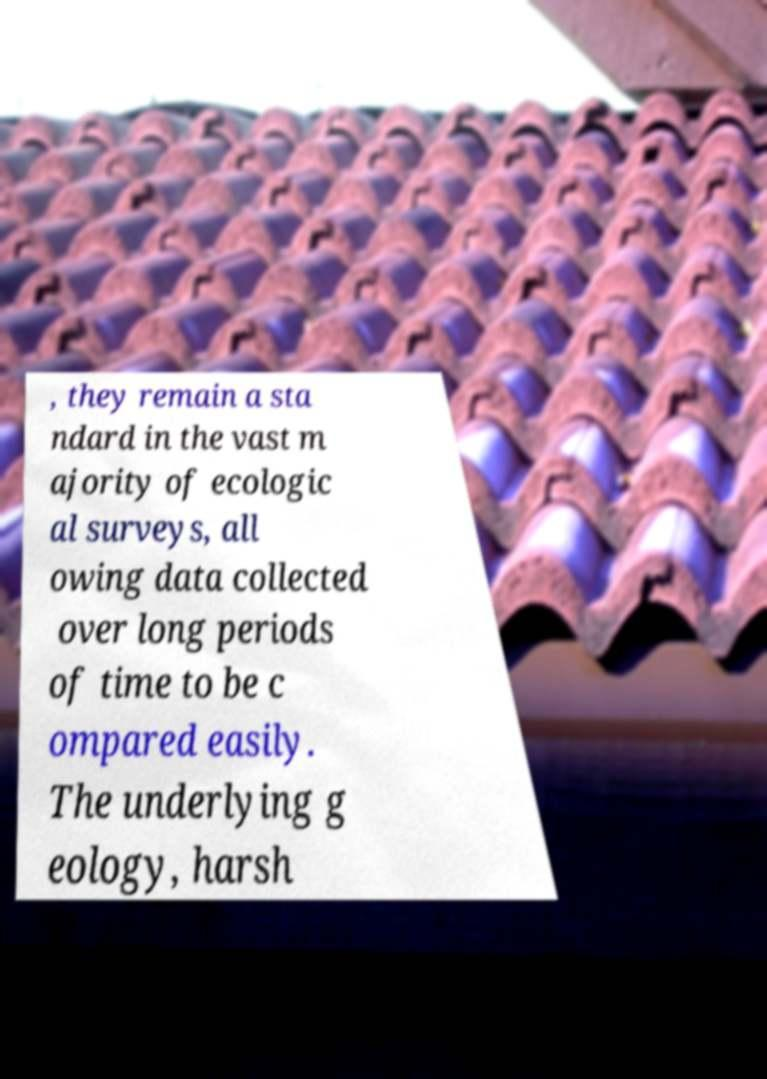Could you extract and type out the text from this image? , they remain a sta ndard in the vast m ajority of ecologic al surveys, all owing data collected over long periods of time to be c ompared easily. The underlying g eology, harsh 